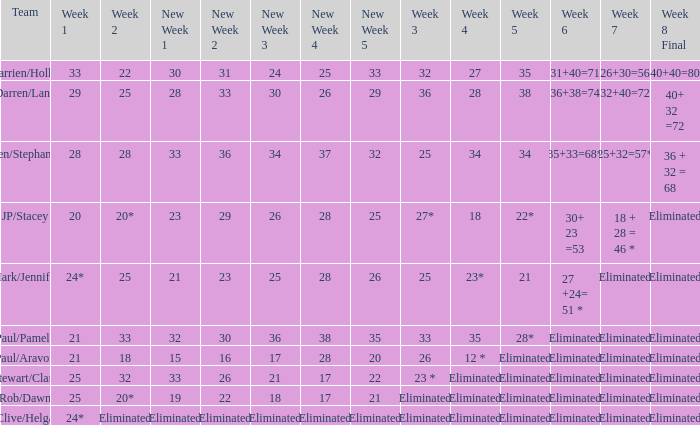Name the week 3 with week 6 of 31+40=71 32.0. Give me the full table as a dictionary. {'header': ['Team', 'Week 1', 'Week 2', 'New Week 1', 'New Week 2', 'New Week 3', 'New Week 4', 'New Week 5', 'Week 3', 'Week 4', 'Week 5', 'Week 6', 'Week 7', 'Week 8 Final'], 'rows': [['Darrien/Hollie', '33', '22', '30', '31', '24', '25', '33', '32', '27', '35', '31+40=71', '26+30=56', '40+40=80'], ['Darren/Lana', '29', '25', '28', '33', '30', '26', '29', '36', '28', '38', '36+38=74', '32+40=72', '40+ 32 =72'], ['Ben/Stephanie', '28', '28', '33', '36', '34', '37', '32', '25', '34', '34', '35+33=68*', '25+32=57*', '36 + 32 = 68'], ['JP/Stacey', '20', '20*', '23', '29', '26', '28', '25', '27*', '18', '22*', '30+ 23 =53', '18 + 28 = 46 *', 'Eliminated'], ['Mark/Jennifer', '24*', '25', '21', '23', '25', '28', '26', '25', '23*', '21', '27 +24= 51 *', 'Eliminated', 'Eliminated'], ['Paul/Pamela', '21', '33', '32', '30', '36', '38', '35', '33', '35', '28*', 'Eliminated', 'Eliminated', 'Eliminated'], ['Paul/Aravon', '21', '18', '15', '16', '17', '28', '20', '26', '12 *', 'Eliminated', 'Eliminated', 'Eliminated', 'Eliminated'], ['Stewart/Clare', '25', '32', '33', '26', '21', '17', '22', '23 *', 'Eliminated', 'Eliminated', 'Eliminated', 'Eliminated', 'Eliminated'], ['Rob/Dawn', '25', '20*', '19', '22', '18', '17', '21', 'Eliminated', 'Eliminated', 'Eliminated', 'Eliminated', 'Eliminated', 'Eliminated'], ['Clive/Helga', '24*', 'Eliminated', 'Eliminated', 'Eliminated', 'Eliminated', 'Eliminated', 'Eliminated', 'Eliminated', 'Eliminated', 'Eliminated', 'Eliminated', 'Eliminated', 'Eliminated']]} 